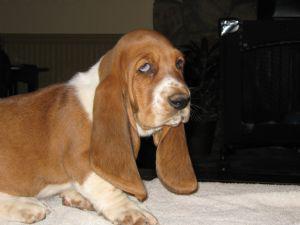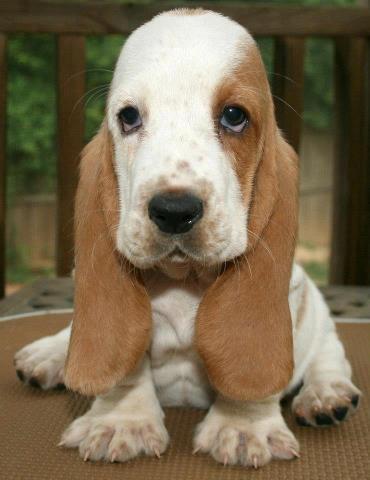The first image is the image on the left, the second image is the image on the right. Examine the images to the left and right. Is the description "Both dogs are sitting down." accurate? Answer yes or no. Yes. The first image is the image on the left, the second image is the image on the right. Analyze the images presented: Is the assertion "There is one basset hound sitting and facing forward and one basset hound facing right and glancing sideways." valid? Answer yes or no. Yes. 